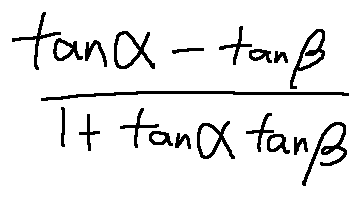Convert formula to latex. <formula><loc_0><loc_0><loc_500><loc_500>\frac { \tan \alpha - \tan \beta } { 1 + \tan \alpha \tan \beta }</formula> 